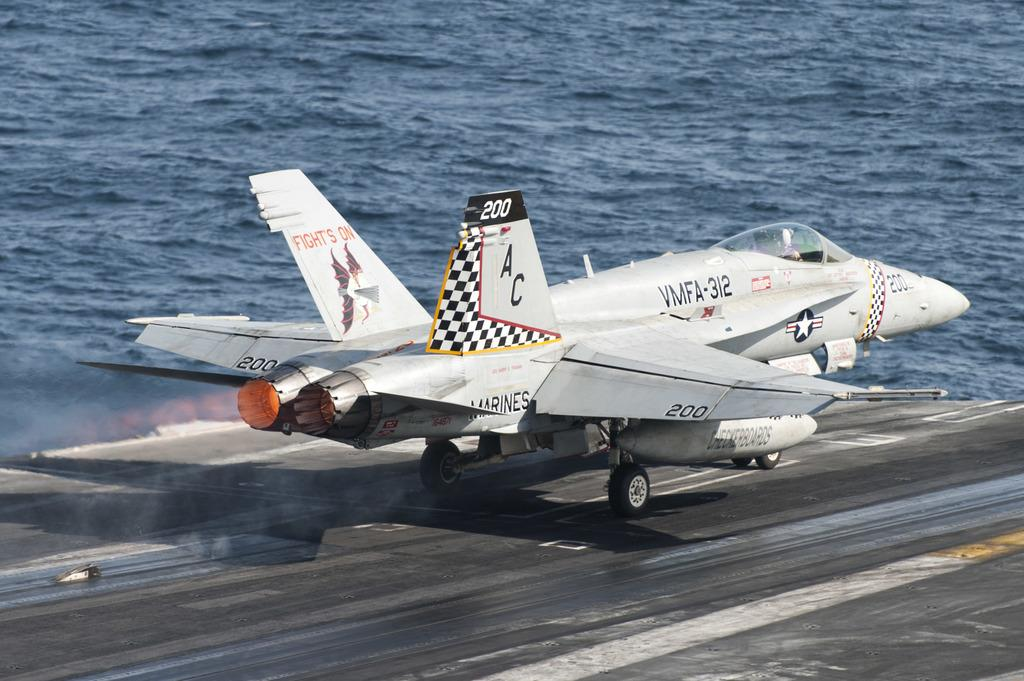<image>
Provide a brief description of the given image. A plane with Fight's On on the tail is on a deck. 